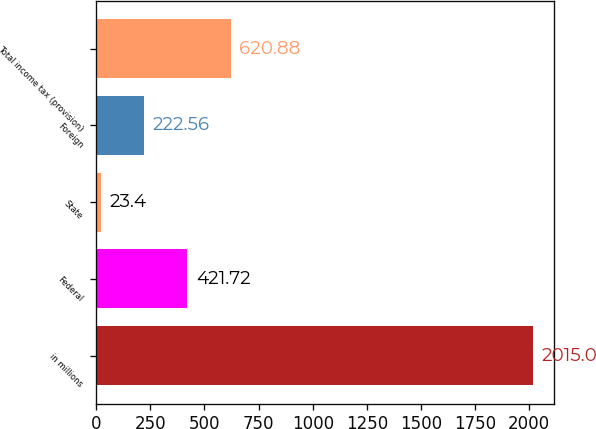Convert chart. <chart><loc_0><loc_0><loc_500><loc_500><bar_chart><fcel>in millions<fcel>Federal<fcel>State<fcel>Foreign<fcel>Total income tax (provision)<nl><fcel>2015<fcel>421.72<fcel>23.4<fcel>222.56<fcel>620.88<nl></chart> 